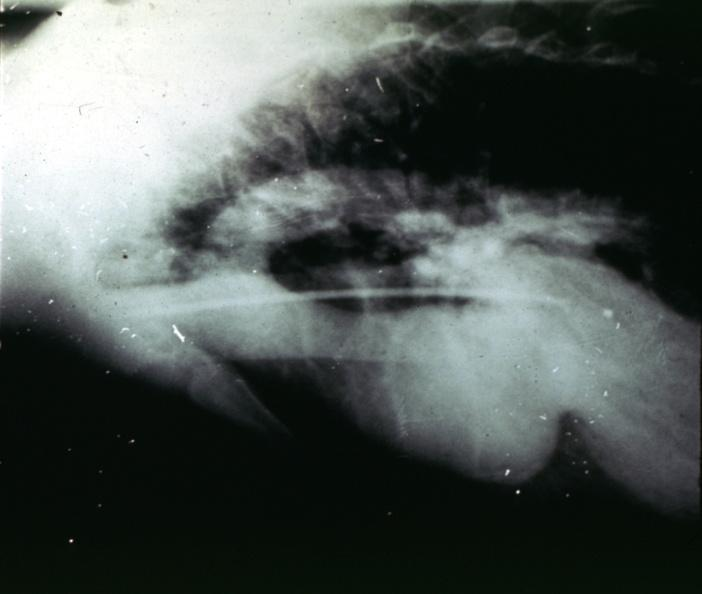what is present?
Answer the question using a single word or phrase. Cardiovascular 